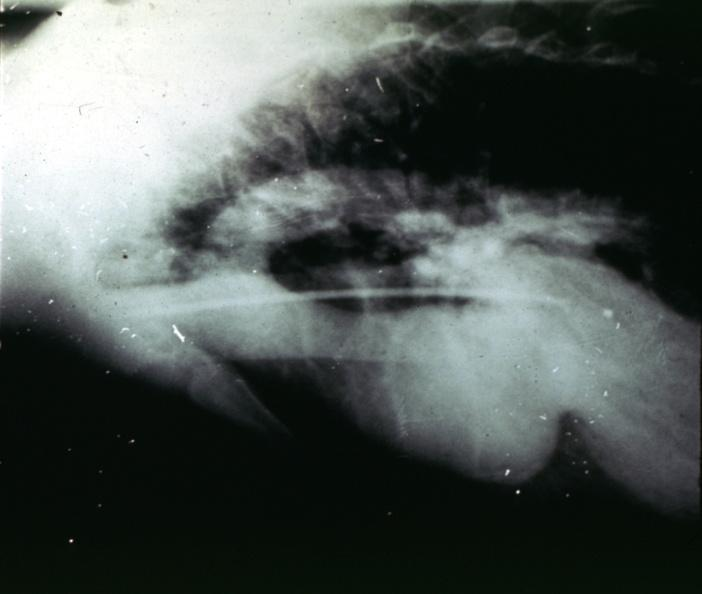what is present?
Answer the question using a single word or phrase. Cardiovascular 